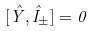Convert formula to latex. <formula><loc_0><loc_0><loc_500><loc_500>[ \hat { Y } , \hat { I } _ { \pm } ] = 0</formula> 